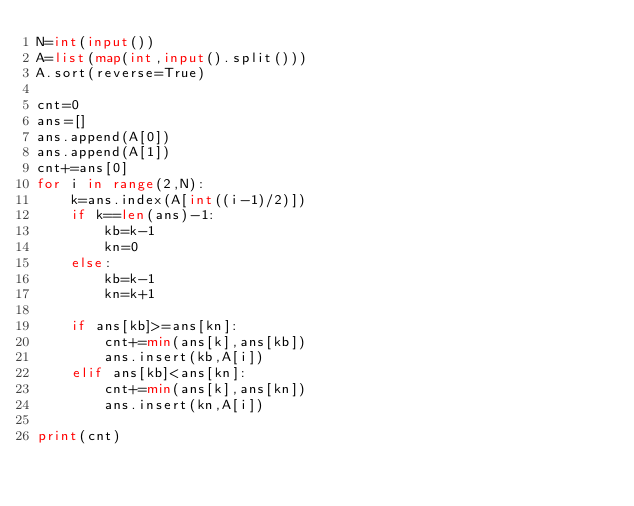<code> <loc_0><loc_0><loc_500><loc_500><_Python_>N=int(input())
A=list(map(int,input().split()))
A.sort(reverse=True)

cnt=0
ans=[]
ans.append(A[0])
ans.append(A[1])
cnt+=ans[0]
for i in range(2,N):
    k=ans.index(A[int((i-1)/2)])
    if k==len(ans)-1:
        kb=k-1
        kn=0
    else:
        kb=k-1
        kn=k+1

    if ans[kb]>=ans[kn]:
        cnt+=min(ans[k],ans[kb])
        ans.insert(kb,A[i])
    elif ans[kb]<ans[kn]:
        cnt+=min(ans[k],ans[kn])
        ans.insert(kn,A[i])

print(cnt)</code> 